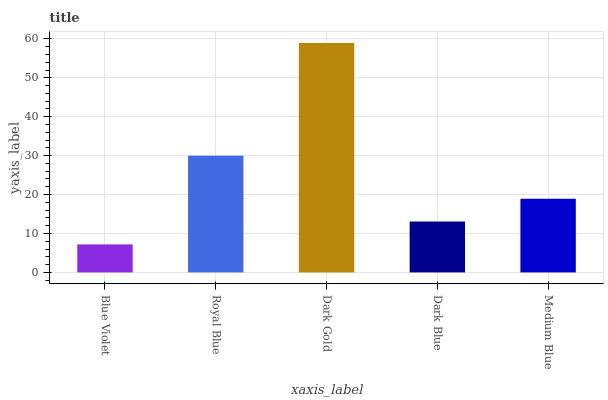Is Blue Violet the minimum?
Answer yes or no. Yes. Is Dark Gold the maximum?
Answer yes or no. Yes. Is Royal Blue the minimum?
Answer yes or no. No. Is Royal Blue the maximum?
Answer yes or no. No. Is Royal Blue greater than Blue Violet?
Answer yes or no. Yes. Is Blue Violet less than Royal Blue?
Answer yes or no. Yes. Is Blue Violet greater than Royal Blue?
Answer yes or no. No. Is Royal Blue less than Blue Violet?
Answer yes or no. No. Is Medium Blue the high median?
Answer yes or no. Yes. Is Medium Blue the low median?
Answer yes or no. Yes. Is Dark Gold the high median?
Answer yes or no. No. Is Royal Blue the low median?
Answer yes or no. No. 